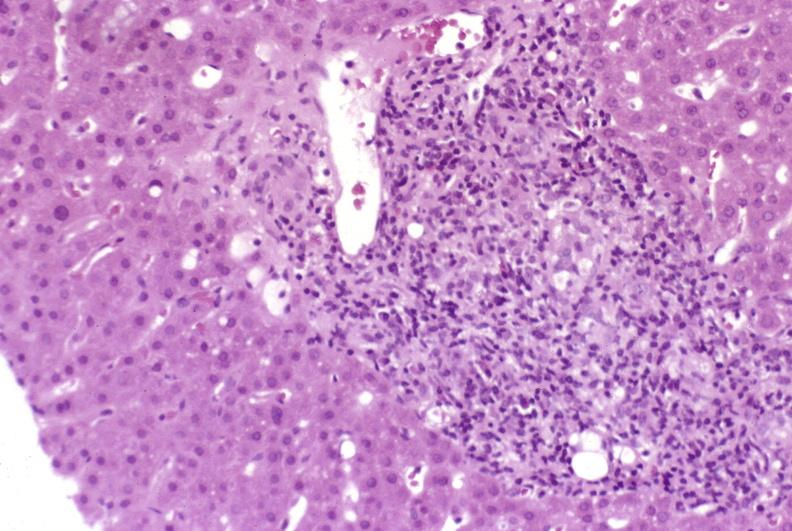does this image show mild-to-moderate acute rejection?
Answer the question using a single word or phrase. Yes 